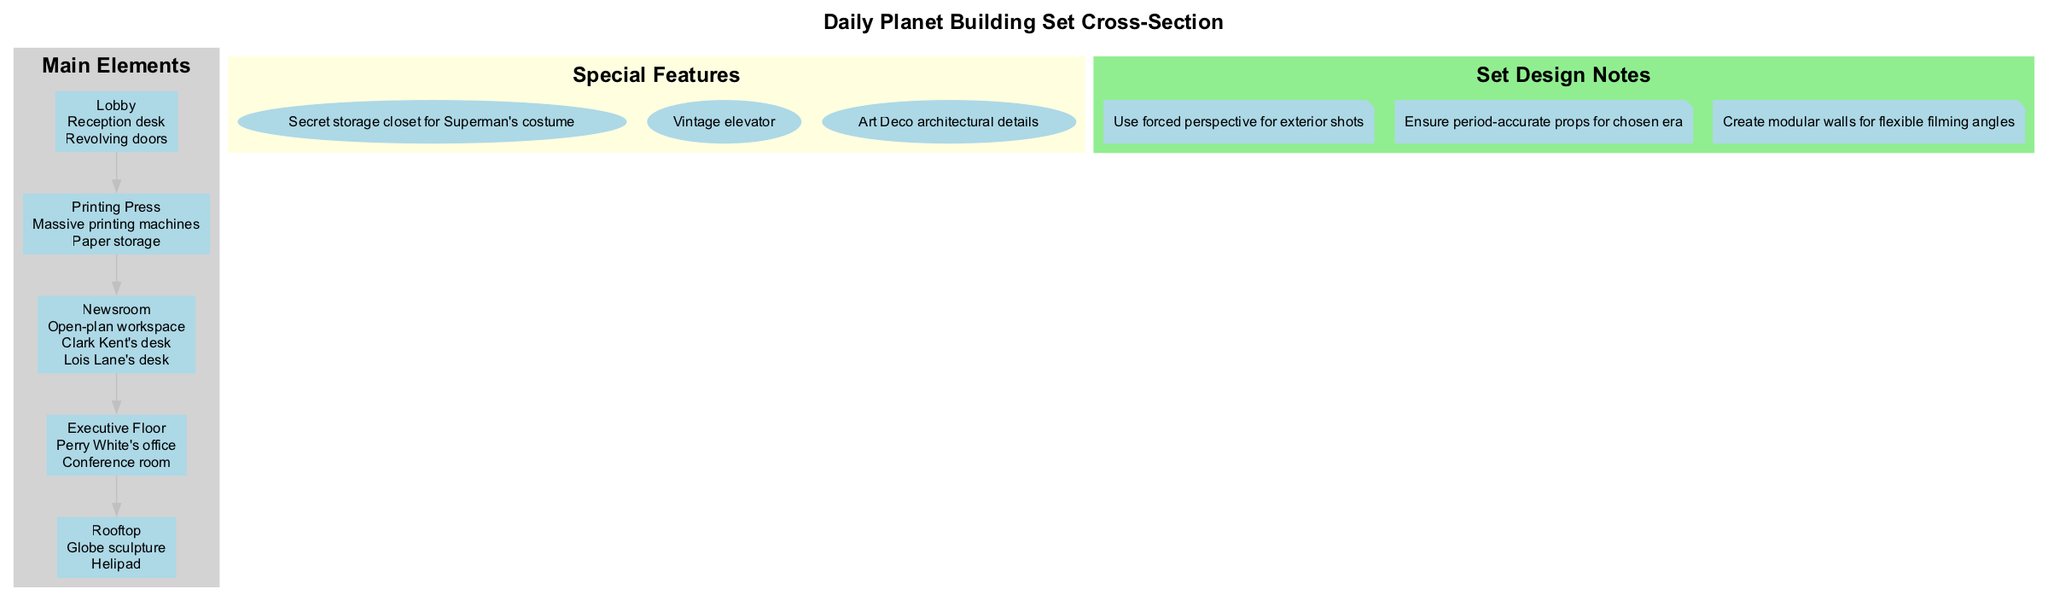What is located on the rooftop of the Daily Planet building? The rooftop contains two features: a globe sculpture and a helipad. This is directly stated in the features listed for the rooftop.
Answer: Globe sculpture, Helipad How many main elements are showcased in the diagram? The number of main elements can be counted in the portion detailing the 'Main Elements'. There are five distinct elements listed: Rooftop, Executive Floor, Newsroom, Printing Press, and Lobby.
Answer: 5 What feature is found in the Executive Floor? The Executive Floor lists two notable features: Perry White's office and a conference room. The question refers to specific elements mentioned in this section.
Answer: Perry White's office Which special feature is related to Superman? Among the special features, there is a 'secret storage closet for Superman's costume' noted. This targets a unique element that connects specifically to the Superman character.
Answer: Secret storage closet for Superman's costume What architectural style details are included in the special features? The diagram indicates the inclusion of 'Art Deco architectural details' in the special features. This is specific to the architectural style associated with the building's design.
Answer: Art Deco architectural details What element is connected to both the Executive Floor and the Newsroom? The edges between the nodes represent the relationships, and while there are no direct connections stated, both floors are considered significant parts of the building's structure. Thus, we can summarize that both are essential parts of the Daily Planet building.
Answer: None, they are separate elements What type of workspace is present in the Newsroom? Within the Newsroom's features, it notes an 'open-plan workspace'. This is a specific descriptor for how the workspace is organized.
Answer: Open-plan workspace How would set design notes influence filming angles? The set design notes mention to 'create modular walls for flexible filming angles', indicating that the structure of the set can be adjusted to enhance how the film is shot. This suggests a practical application of the design notes for filming.
Answer: Create modular walls for flexible filming angles What element contains massive printing machines? The 'Printing Press' section describes massive printing machines explicitly as one of its two features. This clearly identifies which part of the building contains this element.
Answer: Printing Press 